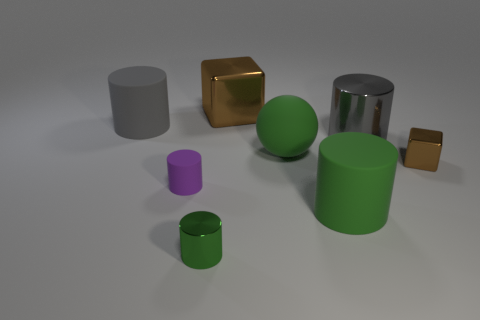Are the green ball and the brown block behind the big gray metal cylinder made of the same material?
Provide a short and direct response. No. There is a large cylinder on the left side of the brown metal cube to the left of the small thing that is behind the small purple rubber cylinder; what color is it?
Your response must be concise. Gray. There is a gray metal thing that is the same size as the green ball; what is its shape?
Keep it short and to the point. Cylinder. There is a brown object behind the gray rubber cylinder; is its size the same as the gray thing on the right side of the large green rubber cylinder?
Your answer should be very brief. Yes. There is a green cylinder that is on the right side of the large brown metallic cube; how big is it?
Provide a succinct answer. Large. What material is the small thing that is the same color as the big block?
Your answer should be compact. Metal. There is a cube that is the same size as the green rubber cylinder; what color is it?
Provide a short and direct response. Brown. Does the sphere have the same size as the purple object?
Keep it short and to the point. No. What size is the metal object that is on the left side of the big green matte ball and in front of the large brown shiny cube?
Ensure brevity in your answer.  Small. How many shiny things are purple cylinders or green objects?
Offer a very short reply. 1. 